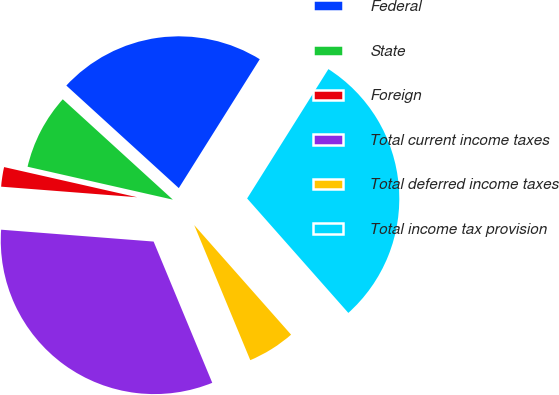<chart> <loc_0><loc_0><loc_500><loc_500><pie_chart><fcel>Federal<fcel>State<fcel>Foreign<fcel>Total current income taxes<fcel>Total deferred income taxes<fcel>Total income tax provision<nl><fcel>22.16%<fcel>8.22%<fcel>2.31%<fcel>32.5%<fcel>5.26%<fcel>29.55%<nl></chart> 